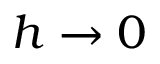<formula> <loc_0><loc_0><loc_500><loc_500>h \rightarrow 0</formula> 